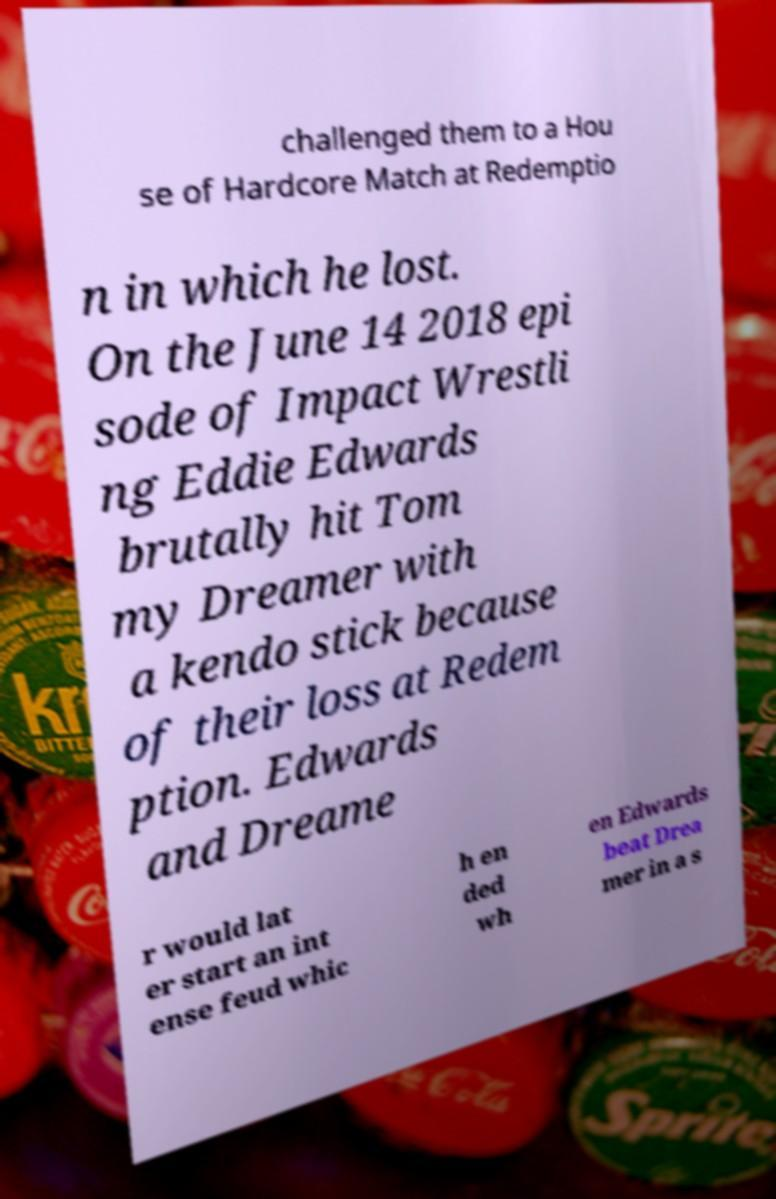Please identify and transcribe the text found in this image. challenged them to a Hou se of Hardcore Match at Redemptio n in which he lost. On the June 14 2018 epi sode of Impact Wrestli ng Eddie Edwards brutally hit Tom my Dreamer with a kendo stick because of their loss at Redem ption. Edwards and Dreame r would lat er start an int ense feud whic h en ded wh en Edwards beat Drea mer in a s 